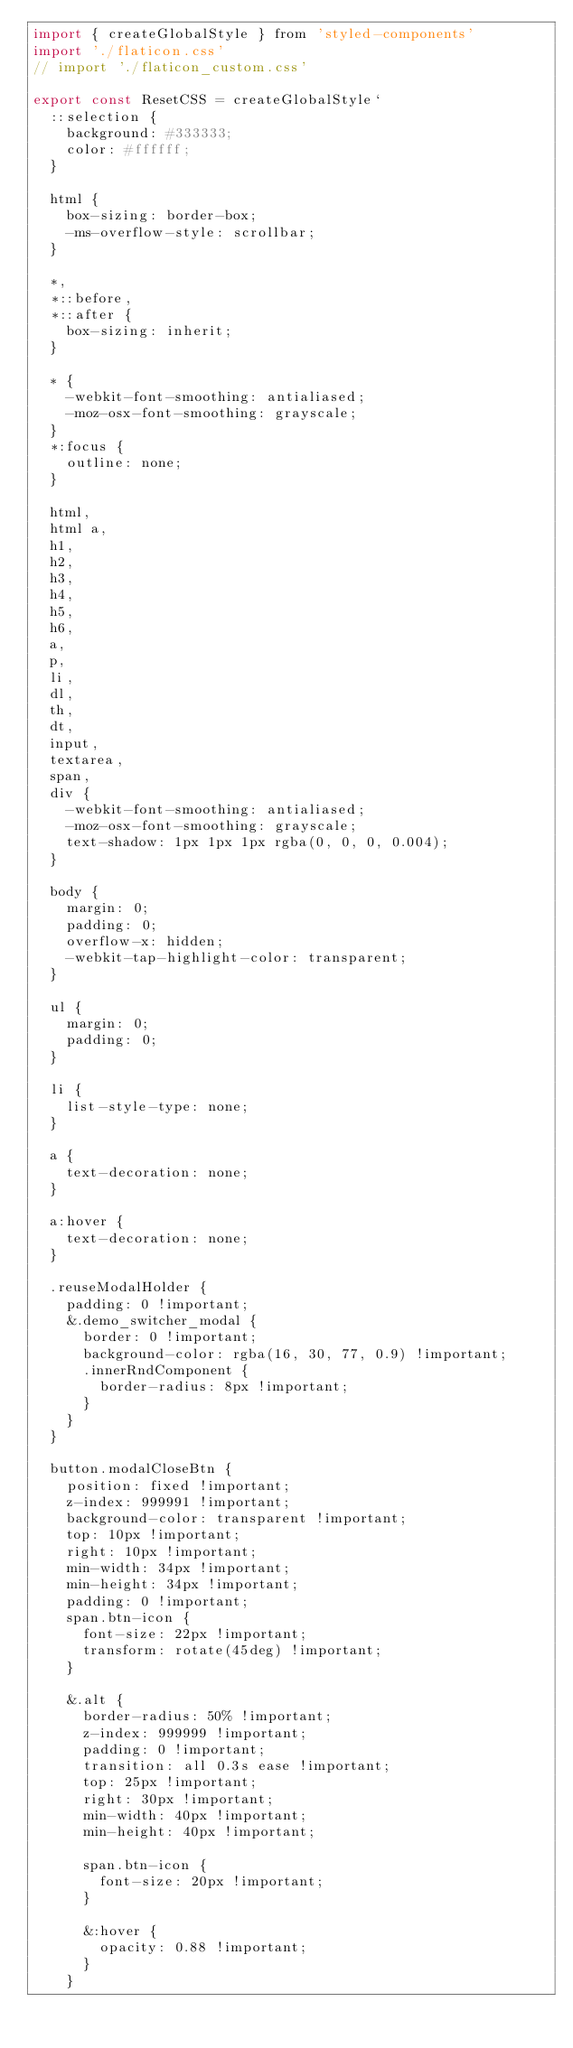Convert code to text. <code><loc_0><loc_0><loc_500><loc_500><_JavaScript_>import { createGlobalStyle } from 'styled-components'
import './flaticon.css'
// import './flaticon_custom.css'

export const ResetCSS = createGlobalStyle`
  ::selection {
    background: #333333;
    color: #ffffff;
  }

  html {
    box-sizing: border-box;
    -ms-overflow-style: scrollbar;
  }

  *,
  *::before,
  *::after {
    box-sizing: inherit;
  }

  * {
    -webkit-font-smoothing: antialiased;
    -moz-osx-font-smoothing: grayscale;
  }
  *:focus {
    outline: none;
  }

  html,
  html a,
  h1,
  h2,
  h3,
  h4,
  h5,
  h6,
  a,
  p,
  li,
  dl,
  th,
  dt,
  input,
  textarea,
  span,
  div {
    -webkit-font-smoothing: antialiased;
    -moz-osx-font-smoothing: grayscale;
    text-shadow: 1px 1px 1px rgba(0, 0, 0, 0.004);
  }

  body {
    margin: 0;
    padding: 0;
    overflow-x: hidden;
    -webkit-tap-highlight-color: transparent;
  }

  ul {
    margin: 0;
    padding: 0;
  }

  li {
    list-style-type: none;
  }

  a {
    text-decoration: none;
  }

  a:hover {
    text-decoration: none;
  }

  .reuseModalHolder {
    padding: 0 !important;
    &.demo_switcher_modal {
      border: 0 !important;
      background-color: rgba(16, 30, 77, 0.9) !important;
      .innerRndComponent {
        border-radius: 8px !important;
      }
    }
  }

  button.modalCloseBtn {
    position: fixed !important;
    z-index: 999991 !important;
    background-color: transparent !important;
    top: 10px !important;
    right: 10px !important;
    min-width: 34px !important;
    min-height: 34px !important;
    padding: 0 !important;
    span.btn-icon {
      font-size: 22px !important;
      transform: rotate(45deg) !important;
    }

    &.alt {
      border-radius: 50% !important;
      z-index: 999999 !important;
      padding: 0 !important;
      transition: all 0.3s ease !important;
      top: 25px !important;
      right: 30px !important;
      min-width: 40px !important;
      min-height: 40px !important;

      span.btn-icon {
        font-size: 20px !important;
      }

      &:hover {
        opacity: 0.88 !important;
      }
    }</code> 